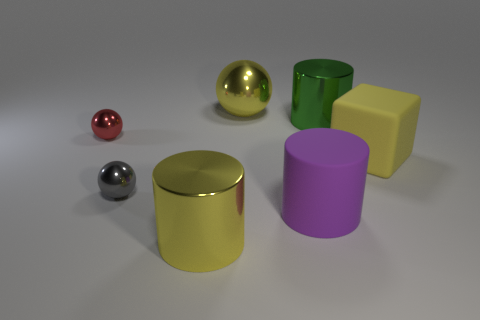Add 1 cyan matte objects. How many objects exist? 8 Subtract all balls. How many objects are left? 4 Add 4 red spheres. How many red spheres exist? 5 Subtract 0 brown cubes. How many objects are left? 7 Subtract all green matte cubes. Subtract all metallic cylinders. How many objects are left? 5 Add 1 purple cylinders. How many purple cylinders are left? 2 